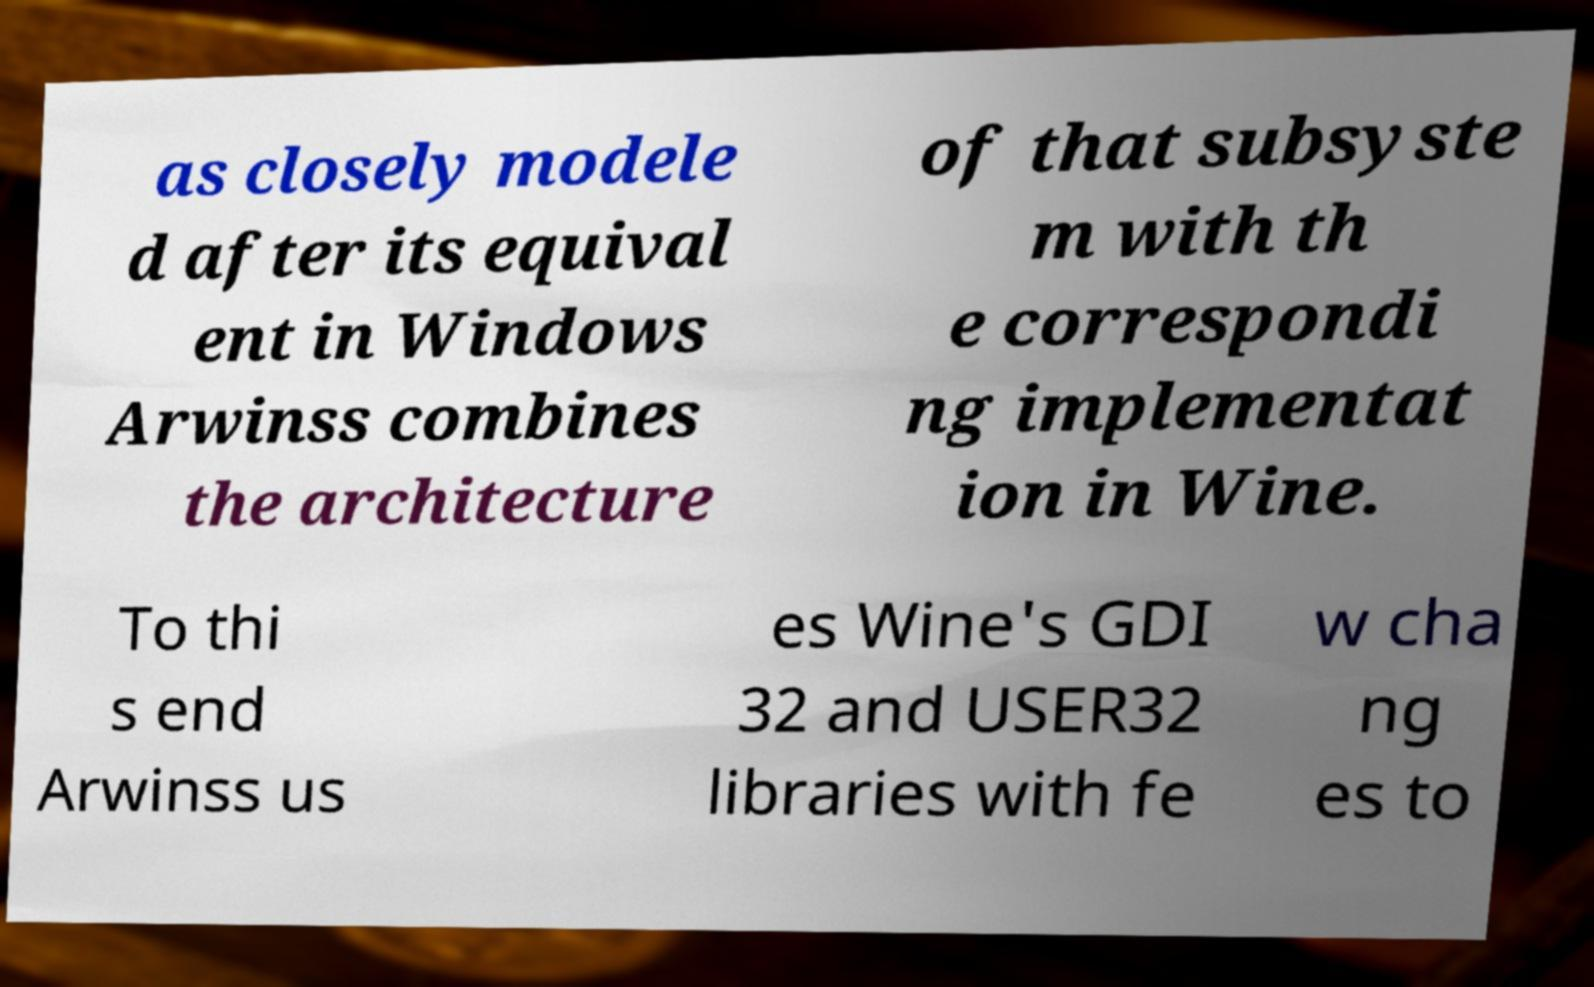Can you read and provide the text displayed in the image?This photo seems to have some interesting text. Can you extract and type it out for me? as closely modele d after its equival ent in Windows Arwinss combines the architecture of that subsyste m with th e correspondi ng implementat ion in Wine. To thi s end Arwinss us es Wine's GDI 32 and USER32 libraries with fe w cha ng es to 